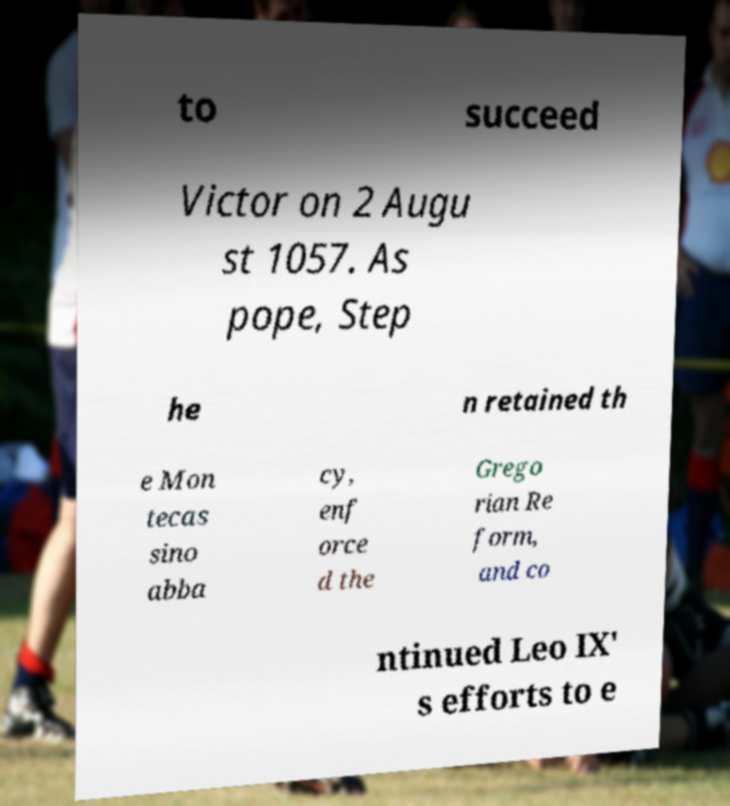Can you read and provide the text displayed in the image?This photo seems to have some interesting text. Can you extract and type it out for me? to succeed Victor on 2 Augu st 1057. As pope, Step he n retained th e Mon tecas sino abba cy, enf orce d the Grego rian Re form, and co ntinued Leo IX' s efforts to e 